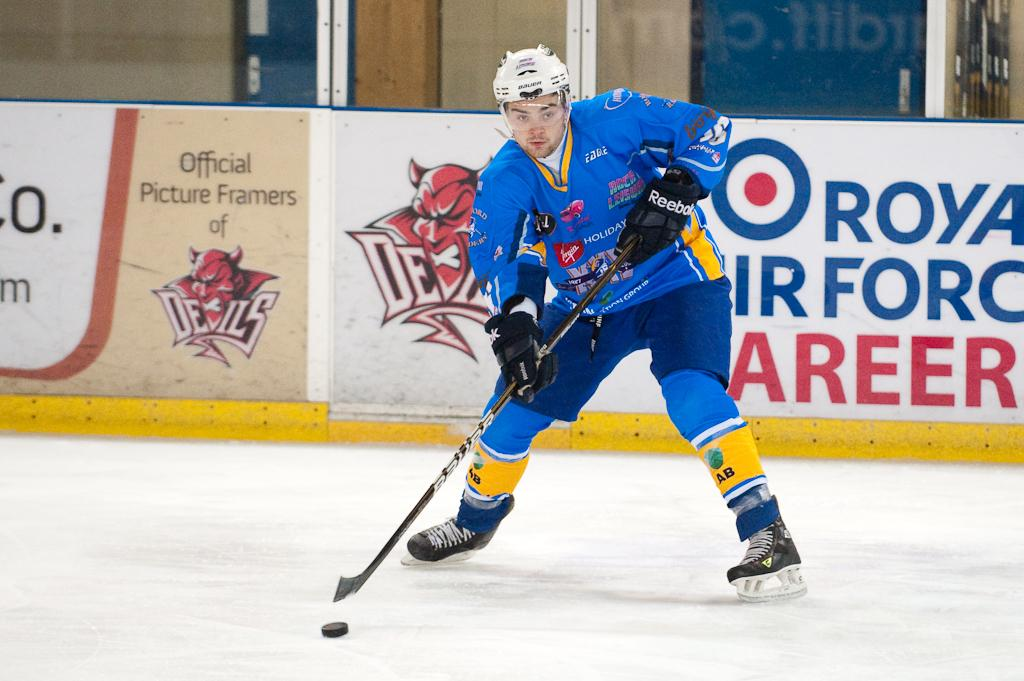<image>
Describe the image concisely. An ice hockey match is sponsored by the Royal Airforce. 